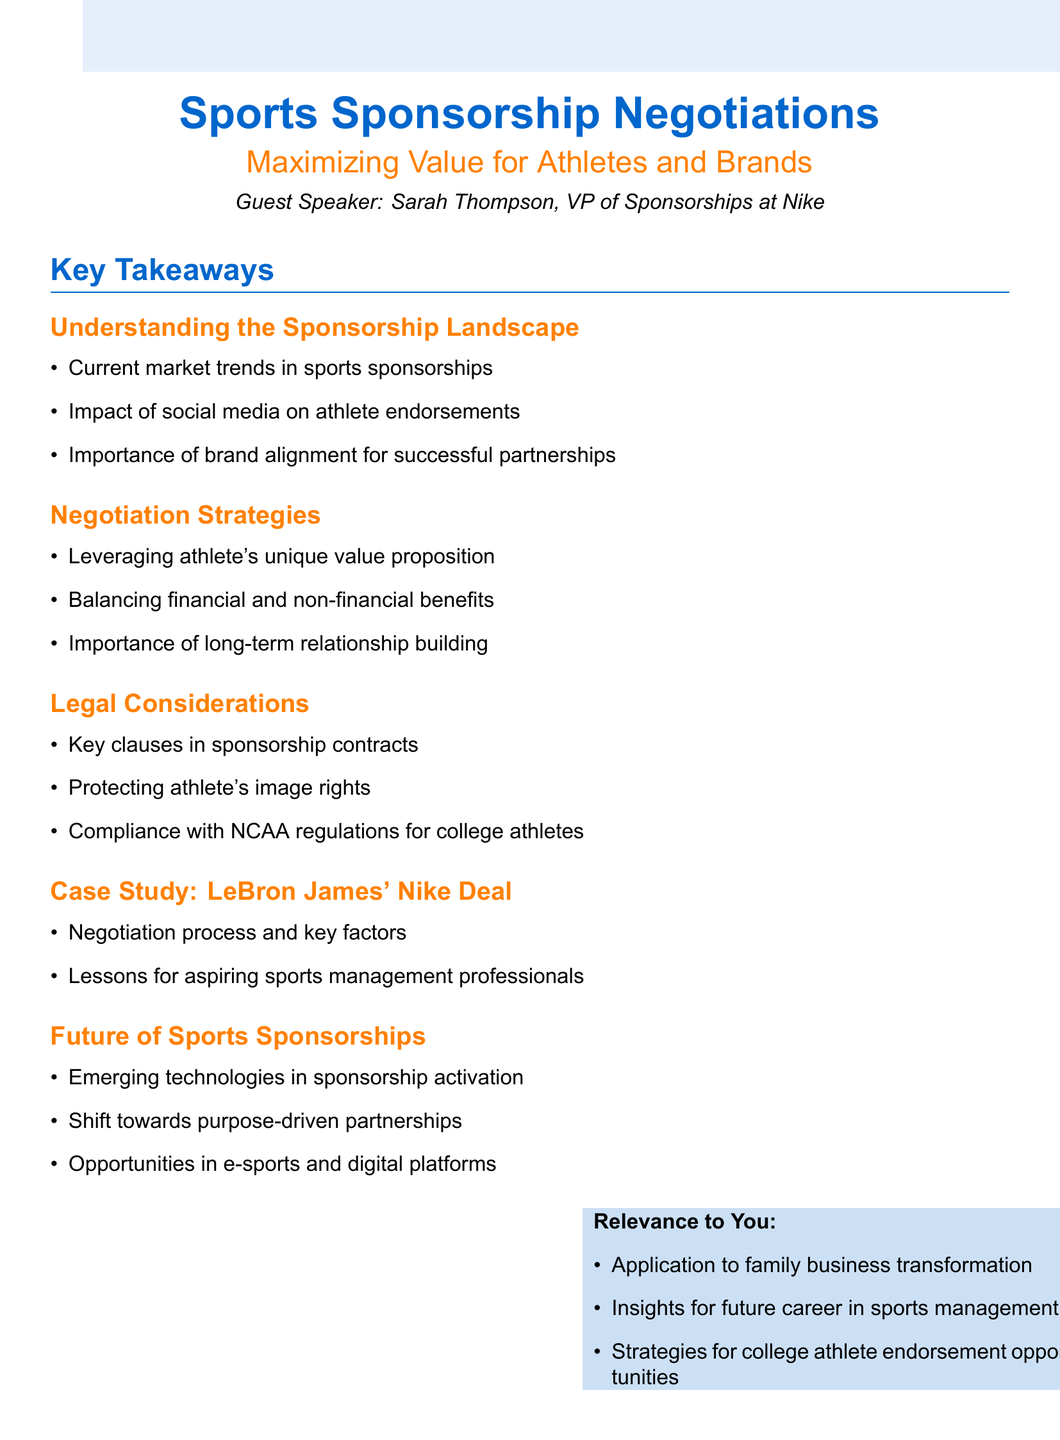What is the title of the lecture? The title of the lecture is stated at the beginning of the document.
Answer: Sports Sponsorship Negotiations: Maximizing Value for Athletes and Brands Who is the guest speaker? The guest speaker is mentioned prominently in the introduction section of the document.
Answer: Sarah Thompson What are current trends in sports sponsorships? Current market trends in sports sponsorships are listed under the topic "Understanding the Sponsorship Landscape."
Answer: Current market trends in sports sponsorships What is a key negotiation strategy mentioned? A specific negotiation strategy is listed in the "Negotiation Strategies" section of the document.
Answer: Leveraging athlete's unique value proposition What is a legal consideration in sponsorship contracts? Legal considerations are discussed in the "Legal Considerations" section of the document.
Answer: Key clauses in sponsorship contracts What is one lesson learned from the LeBron James case study? The lessons learned from the case study are provided in the "Case Study" section.
Answer: Lessons learned for aspiring sports management professionals What emerging opportunity is highlighted for the future of sponsorships? Opportunities in e-sports and digital platforms are mentioned under the "Future of Sports Sponsorships."
Answer: Opportunities in e-sports and digital platforms How does this lecture relate to your future career? The relevance to the persona is detailed in the last section of the document.
Answer: Insights for future career in sports management 